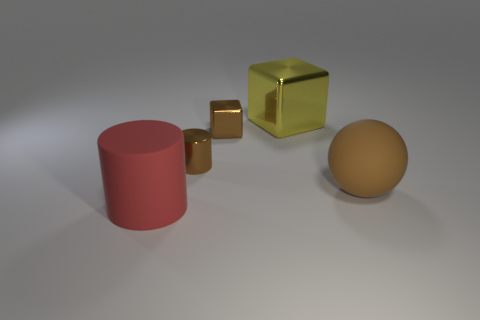Are there any reflections visible in the objects? Yes, there are reflections visible. The golden cube and the larger yellow cube both exhibit a reflective quality. The metallic sheen on the yellow cube reflects the environment and the small golden cube serves as a mirror-like surface that also reflects the setting, demonstrating the properties of their shiny finishes. What can be inferred about the light source in the image? The light in the image appears to be coming from above, casting soft shadows below the objects to their right sides, suggesting a single diffused and possibly distant light source. This is typical of a studio lighting setup where objects are illuminated to highlight their form and texture without causing harsh shadows. 